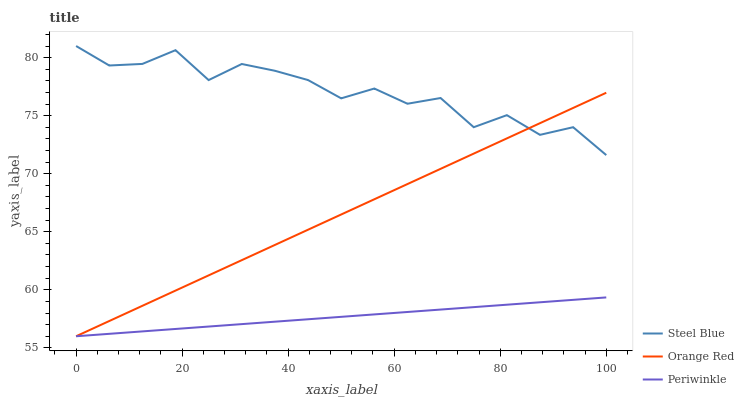Does Orange Red have the minimum area under the curve?
Answer yes or no. No. Does Orange Red have the maximum area under the curve?
Answer yes or no. No. Is Orange Red the smoothest?
Answer yes or no. No. Is Orange Red the roughest?
Answer yes or no. No. Does Steel Blue have the lowest value?
Answer yes or no. No. Does Orange Red have the highest value?
Answer yes or no. No. Is Periwinkle less than Steel Blue?
Answer yes or no. Yes. Is Steel Blue greater than Periwinkle?
Answer yes or no. Yes. Does Periwinkle intersect Steel Blue?
Answer yes or no. No. 